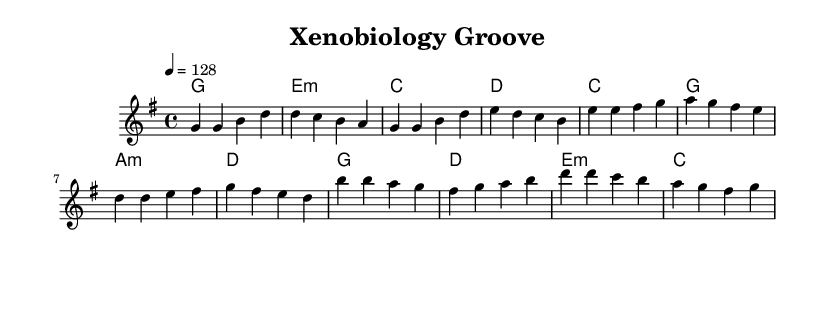What is the key signature of this music? The key signature is G major, which has one sharp (F#). This can be identified by looking at the key signature indicated at the beginning of the staff.
Answer: G major What is the time signature of this music? The time signature is 4/4, indicated at the start of the piece. This means there are four beats in each measure, and the quarter note gets the beat.
Answer: 4/4 What tempo marking is given for this piece? The tempo marking is indicated as "4 = 128," which means there are 128 beats per minute, and each quarter note is counted as 1 beat. This information is crucial for understanding how fast the piece should be played.
Answer: 128 How many measures are in the chorus section? The chorus consists of four measures, as determined by counting the groups of notes in the melody section specified for the chorus. Each line of the music typically represents a measure.
Answer: 4 What chord is used in the first measure of the verse? The first measure of the verse contains the G major chord, which can be identified by looking at the chord names written above the staff. It is the first of the chord symbols.
Answer: G Is there a pre-chorus in this piece? Yes, there is a pre-chorus section. This can be confirmed by examining the structure of the music; specifically, it follows the verse and precedes the chorus, indicated by its unique melody and chord progression.
Answer: Yes Which chord is played in the last measure? The last measure features the C major chord. This can be concluded by observing the final chord in the harmony section at the end of the score.
Answer: C 